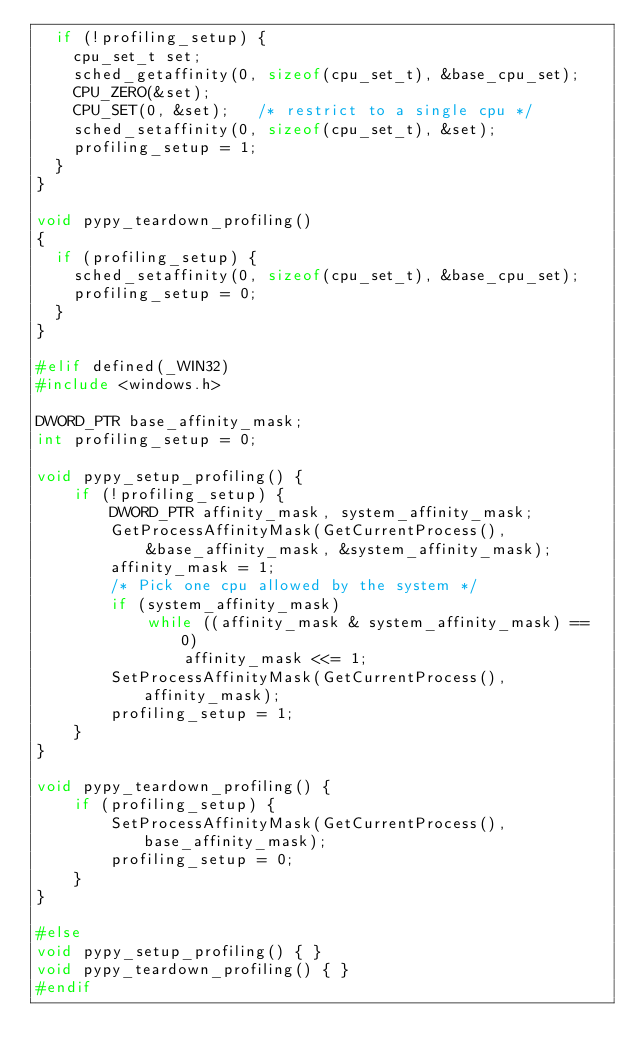<code> <loc_0><loc_0><loc_500><loc_500><_C_>  if (!profiling_setup) {
    cpu_set_t set;
    sched_getaffinity(0, sizeof(cpu_set_t), &base_cpu_set);
    CPU_ZERO(&set);
    CPU_SET(0, &set);   /* restrict to a single cpu */
    sched_setaffinity(0, sizeof(cpu_set_t), &set);
    profiling_setup = 1;
  }
}

void pypy_teardown_profiling()
{
  if (profiling_setup) {
    sched_setaffinity(0, sizeof(cpu_set_t), &base_cpu_set);
    profiling_setup = 0;
  }
}

#elif defined(_WIN32)
#include <windows.h>

DWORD_PTR base_affinity_mask;
int profiling_setup = 0;

void pypy_setup_profiling() { 
    if (!profiling_setup) {
        DWORD_PTR affinity_mask, system_affinity_mask;
        GetProcessAffinityMask(GetCurrentProcess(),
            &base_affinity_mask, &system_affinity_mask);
        affinity_mask = 1;
        /* Pick one cpu allowed by the system */
        if (system_affinity_mask)
            while ((affinity_mask & system_affinity_mask) == 0)
                affinity_mask <<= 1;
        SetProcessAffinityMask(GetCurrentProcess(), affinity_mask);
        profiling_setup = 1;
    }
}

void pypy_teardown_profiling() {
    if (profiling_setup) {
        SetProcessAffinityMask(GetCurrentProcess(), base_affinity_mask);
        profiling_setup = 0;
    }
}

#else
void pypy_setup_profiling() { }
void pypy_teardown_profiling() { }
#endif
</code> 